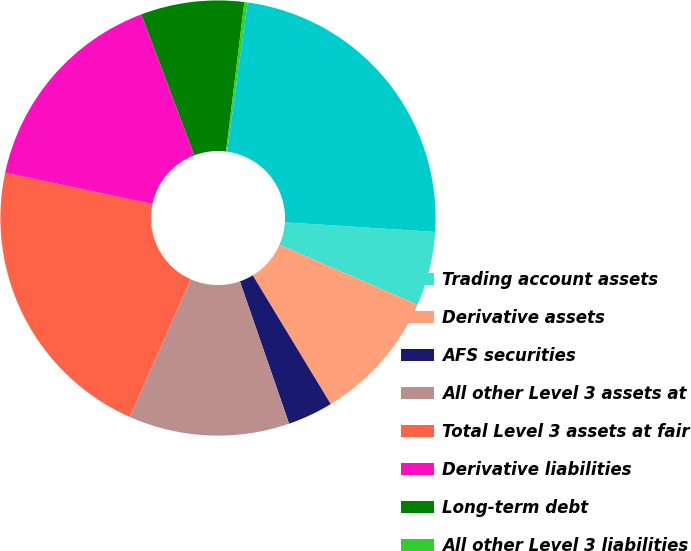<chart> <loc_0><loc_0><loc_500><loc_500><pie_chart><fcel>Trading account assets<fcel>Derivative assets<fcel>AFS securities<fcel>All other Level 3 assets at<fcel>Total Level 3 assets at fair<fcel>Derivative liabilities<fcel>Long-term debt<fcel>All other Level 3 liabilities<fcel>Total Level 3 liabilities at<nl><fcel>5.51%<fcel>9.8%<fcel>3.37%<fcel>11.95%<fcel>21.69%<fcel>15.93%<fcel>7.66%<fcel>0.24%<fcel>23.84%<nl></chart> 